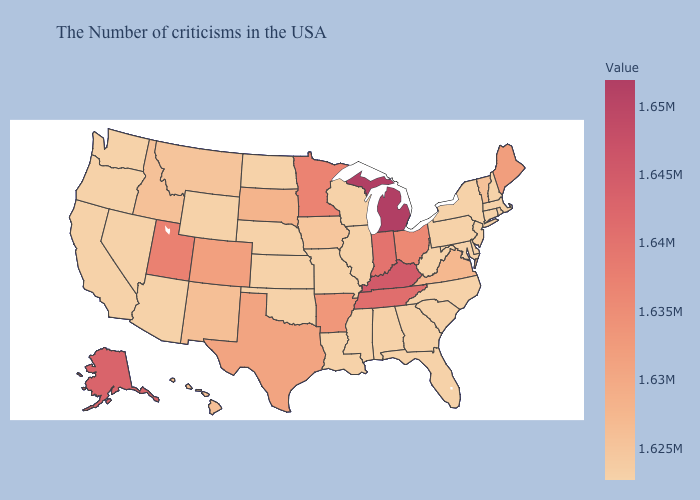Which states have the lowest value in the USA?
Write a very short answer. Massachusetts, Rhode Island, New Hampshire, Connecticut, New York, New Jersey, Delaware, Maryland, Pennsylvania, North Carolina, South Carolina, West Virginia, Florida, Georgia, Alabama, Wisconsin, Illinois, Mississippi, Louisiana, Missouri, Kansas, Nebraska, Oklahoma, North Dakota, Wyoming, Arizona, Nevada, California, Washington. Does Texas have a lower value than Kentucky?
Quick response, please. Yes. Does California have the lowest value in the West?
Write a very short answer. Yes. Does New York have the lowest value in the Northeast?
Be succinct. Yes. Which states hav the highest value in the South?
Keep it brief. Kentucky. Which states have the highest value in the USA?
Keep it brief. Michigan. 